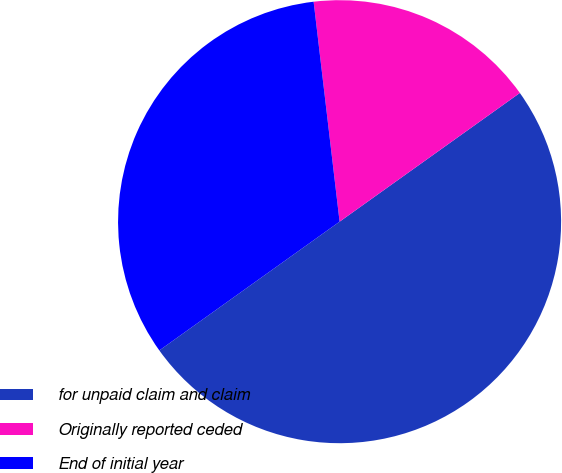<chart> <loc_0><loc_0><loc_500><loc_500><pie_chart><fcel>for unpaid claim and claim<fcel>Originally reported ceded<fcel>End of initial year<nl><fcel>50.0%<fcel>17.0%<fcel>33.0%<nl></chart> 